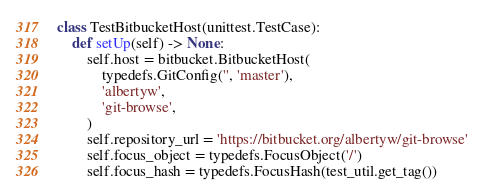Convert code to text. <code><loc_0><loc_0><loc_500><loc_500><_Python_>class TestBitbucketHost(unittest.TestCase):
    def setUp(self) -> None:
        self.host = bitbucket.BitbucketHost(
            typedefs.GitConfig('', 'master'),
            'albertyw',
            'git-browse',
        )
        self.repository_url = 'https://bitbucket.org/albertyw/git-browse'
        self.focus_object = typedefs.FocusObject('/')
        self.focus_hash = typedefs.FocusHash(test_util.get_tag())
</code> 